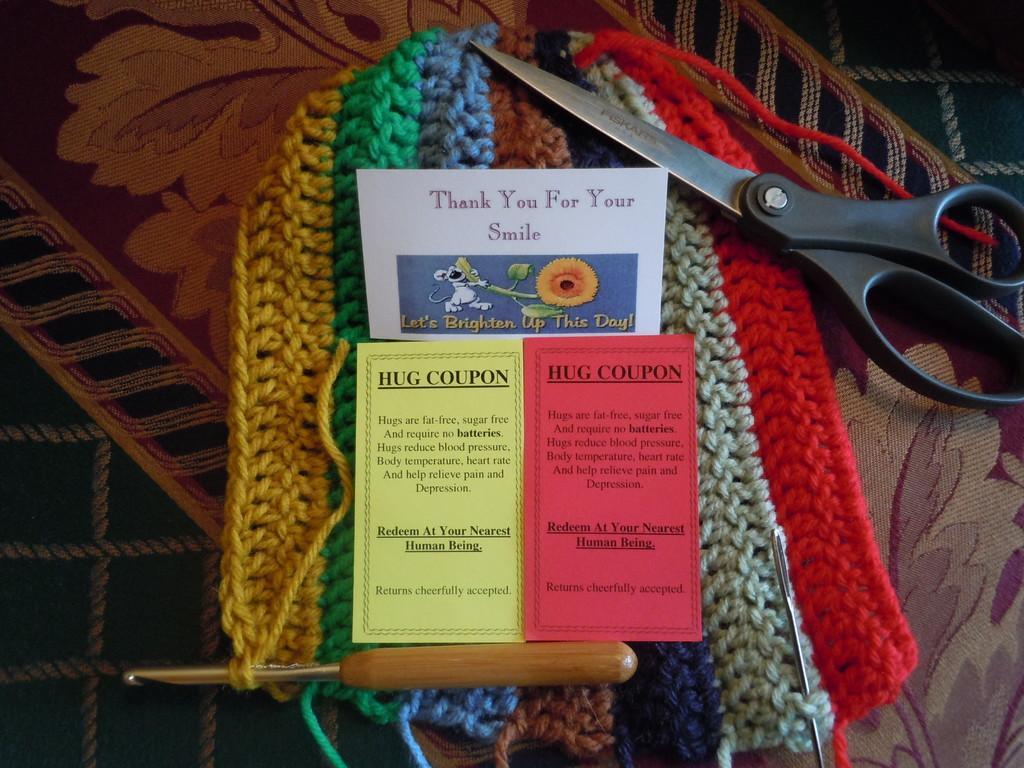Can you describe this image briefly? In the image in the center, we can see the banners, woolens in different colors, one scissor, woolen needles etc. 